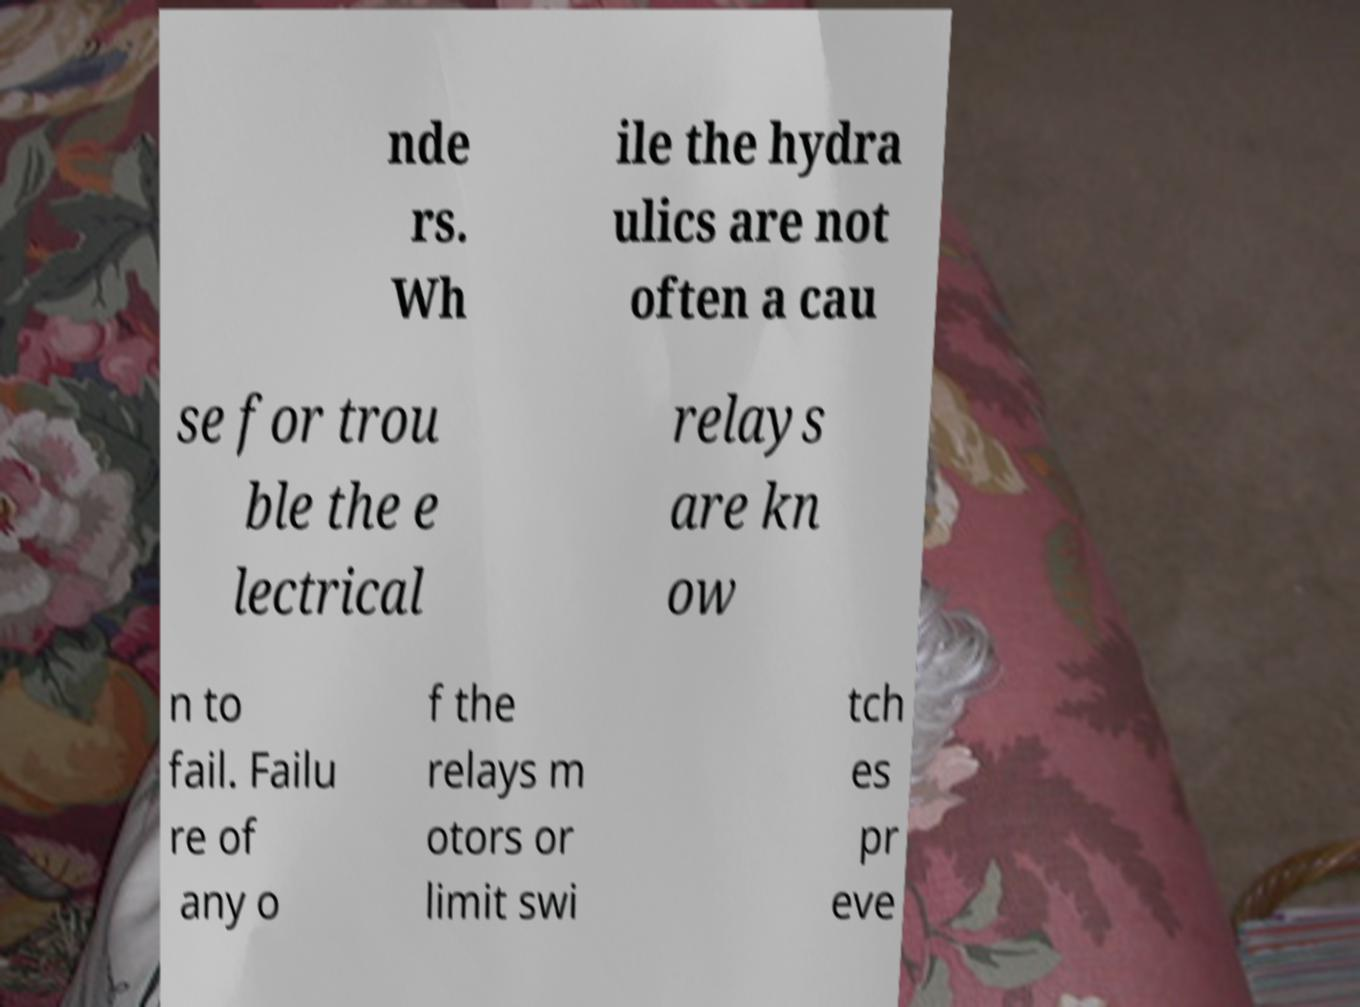For documentation purposes, I need the text within this image transcribed. Could you provide that? nde rs. Wh ile the hydra ulics are not often a cau se for trou ble the e lectrical relays are kn ow n to fail. Failu re of any o f the relays m otors or limit swi tch es pr eve 